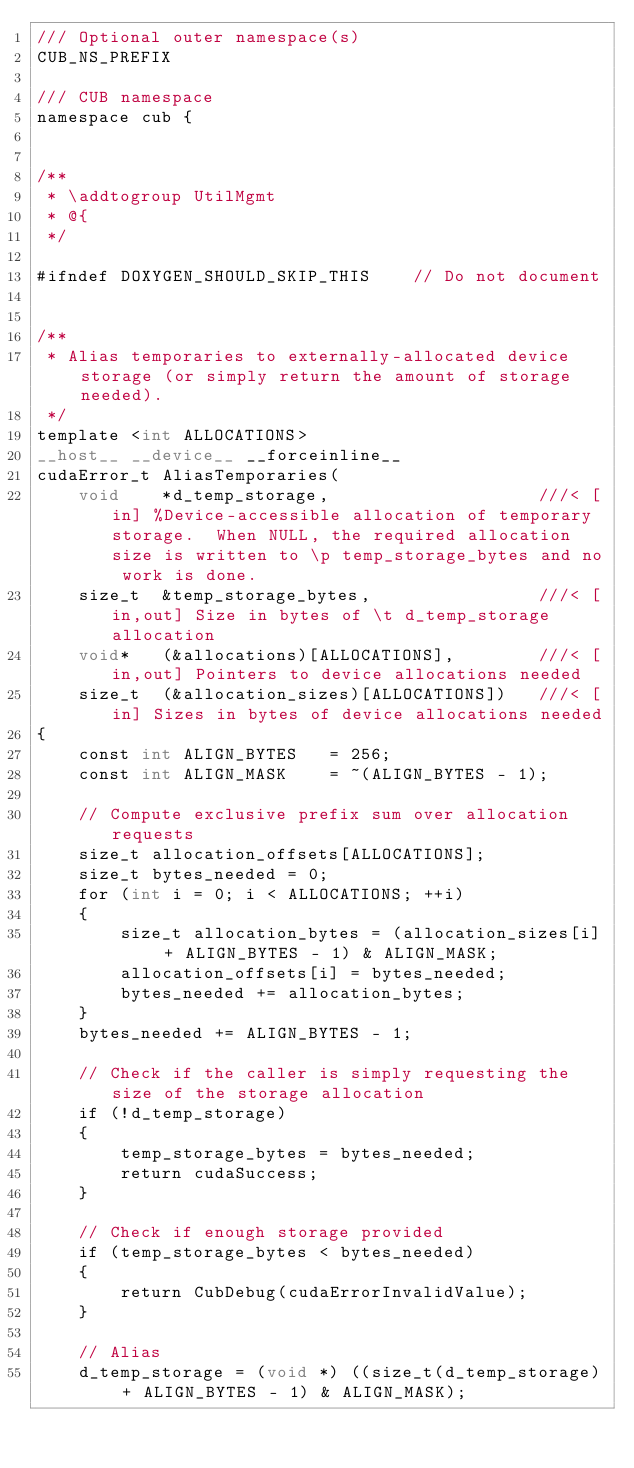<code> <loc_0><loc_0><loc_500><loc_500><_Cuda_>/// Optional outer namespace(s)
CUB_NS_PREFIX

/// CUB namespace
namespace cub {


/**
 * \addtogroup UtilMgmt
 * @{
 */

#ifndef DOXYGEN_SHOULD_SKIP_THIS    // Do not document


/**
 * Alias temporaries to externally-allocated device storage (or simply return the amount of storage needed).
 */
template <int ALLOCATIONS>
__host__ __device__ __forceinline__
cudaError_t AliasTemporaries(
    void    *d_temp_storage,                    ///< [in] %Device-accessible allocation of temporary storage.  When NULL, the required allocation size is written to \p temp_storage_bytes and no work is done.
    size_t  &temp_storage_bytes,                ///< [in,out] Size in bytes of \t d_temp_storage allocation
    void*   (&allocations)[ALLOCATIONS],        ///< [in,out] Pointers to device allocations needed
    size_t  (&allocation_sizes)[ALLOCATIONS])   ///< [in] Sizes in bytes of device allocations needed
{
    const int ALIGN_BYTES   = 256;
    const int ALIGN_MASK    = ~(ALIGN_BYTES - 1);

    // Compute exclusive prefix sum over allocation requests
    size_t allocation_offsets[ALLOCATIONS];
    size_t bytes_needed = 0;
    for (int i = 0; i < ALLOCATIONS; ++i)
    {
        size_t allocation_bytes = (allocation_sizes[i] + ALIGN_BYTES - 1) & ALIGN_MASK;
        allocation_offsets[i] = bytes_needed;
        bytes_needed += allocation_bytes;
    }
    bytes_needed += ALIGN_BYTES - 1;

    // Check if the caller is simply requesting the size of the storage allocation
    if (!d_temp_storage)
    {
        temp_storage_bytes = bytes_needed;
        return cudaSuccess;
    }

    // Check if enough storage provided
    if (temp_storage_bytes < bytes_needed)
    {
        return CubDebug(cudaErrorInvalidValue);
    }

    // Alias
    d_temp_storage = (void *) ((size_t(d_temp_storage) + ALIGN_BYTES - 1) & ALIGN_MASK);</code> 